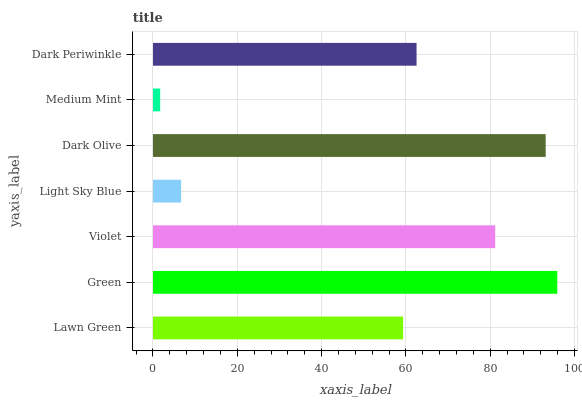Is Medium Mint the minimum?
Answer yes or no. Yes. Is Green the maximum?
Answer yes or no. Yes. Is Violet the minimum?
Answer yes or no. No. Is Violet the maximum?
Answer yes or no. No. Is Green greater than Violet?
Answer yes or no. Yes. Is Violet less than Green?
Answer yes or no. Yes. Is Violet greater than Green?
Answer yes or no. No. Is Green less than Violet?
Answer yes or no. No. Is Dark Periwinkle the high median?
Answer yes or no. Yes. Is Dark Periwinkle the low median?
Answer yes or no. Yes. Is Dark Olive the high median?
Answer yes or no. No. Is Violet the low median?
Answer yes or no. No. 